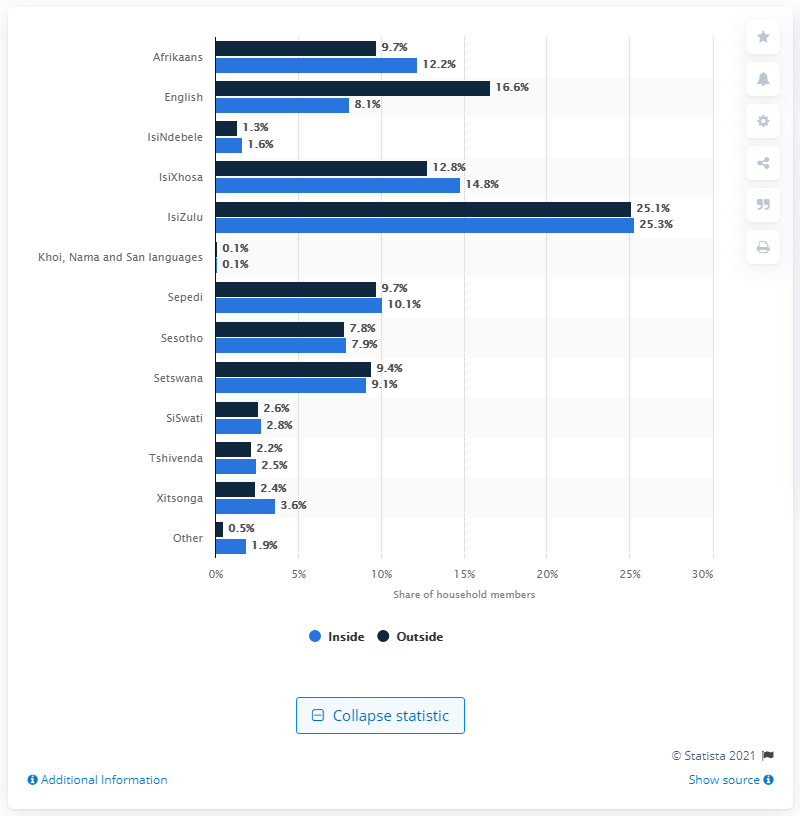Identify some key points in this picture. According to data from 2011, approximately 8.1% of South African households primarily speak English. 